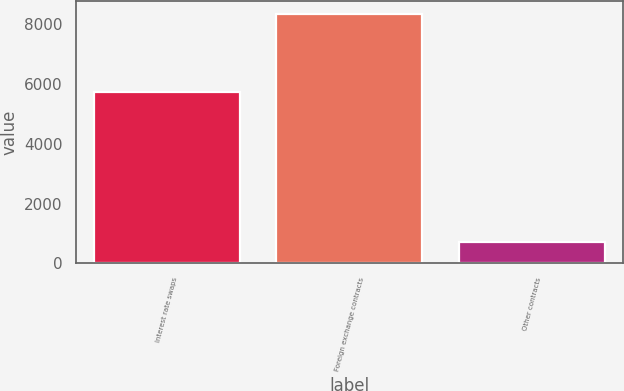Convert chart. <chart><loc_0><loc_0><loc_500><loc_500><bar_chart><fcel>Interest rate swaps<fcel>Foreign exchange contracts<fcel>Other contracts<nl><fcel>5750<fcel>8359<fcel>730<nl></chart> 